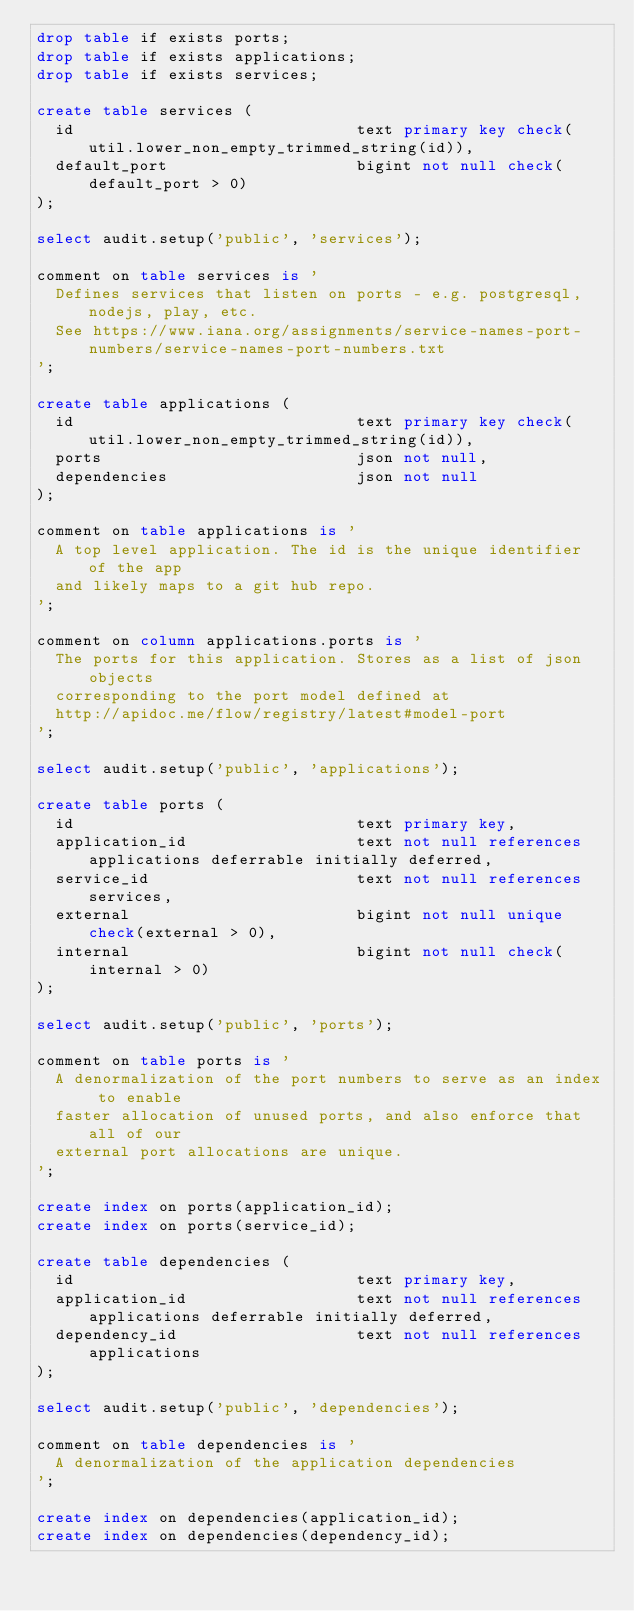<code> <loc_0><loc_0><loc_500><loc_500><_SQL_>drop table if exists ports;
drop table if exists applications;
drop table if exists services;

create table services (
  id                              text primary key check(util.lower_non_empty_trimmed_string(id)),
  default_port                    bigint not null check(default_port > 0)
);

select audit.setup('public', 'services');

comment on table services is '
  Defines services that listen on ports - e.g. postgresql, nodejs, play, etc.
  See https://www.iana.org/assignments/service-names-port-numbers/service-names-port-numbers.txt
';

create table applications (
  id                              text primary key check(util.lower_non_empty_trimmed_string(id)),
  ports                           json not null,
  dependencies                    json not null
);

comment on table applications is '
  A top level application. The id is the unique identifier of the app
  and likely maps to a git hub repo.
';

comment on column applications.ports is '
  The ports for this application. Stores as a list of json objects
  corresponding to the port model defined at
  http://apidoc.me/flow/registry/latest#model-port
';

select audit.setup('public', 'applications');

create table ports (
  id                              text primary key,
  application_id                  text not null references applications deferrable initially deferred,
  service_id                      text not null references services,
  external                        bigint not null unique check(external > 0),
  internal                        bigint not null check(internal > 0)
);

select audit.setup('public', 'ports');

comment on table ports is '
  A denormalization of the port numbers to serve as an index to enable
  faster allocation of unused ports, and also enforce that all of our
  external port allocations are unique.
';

create index on ports(application_id);
create index on ports(service_id);

create table dependencies (
  id                              text primary key,
  application_id                  text not null references applications deferrable initially deferred,
  dependency_id                   text not null references applications
);

select audit.setup('public', 'dependencies');

comment on table dependencies is '
  A denormalization of the application dependencies
';

create index on dependencies(application_id);
create index on dependencies(dependency_id);
</code> 